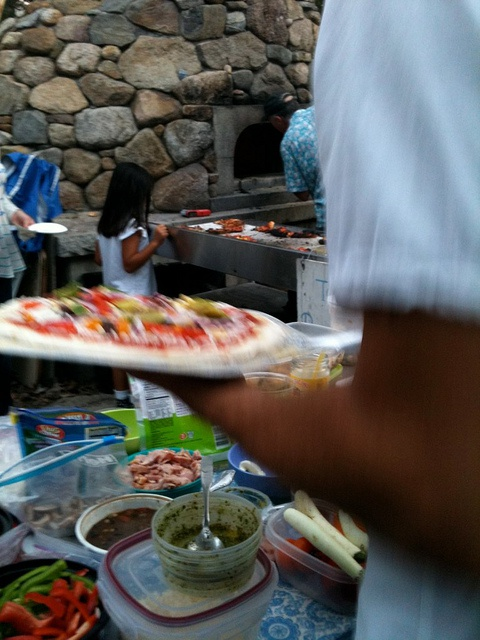Describe the objects in this image and their specific colors. I can see people in tan, black, darkgray, and maroon tones, pizza in tan, lightgray, lightpink, and brown tones, bowl in tan, gray, black, and darkgreen tones, people in tan, black, gray, and maroon tones, and people in tan, black, blue, and gray tones in this image. 